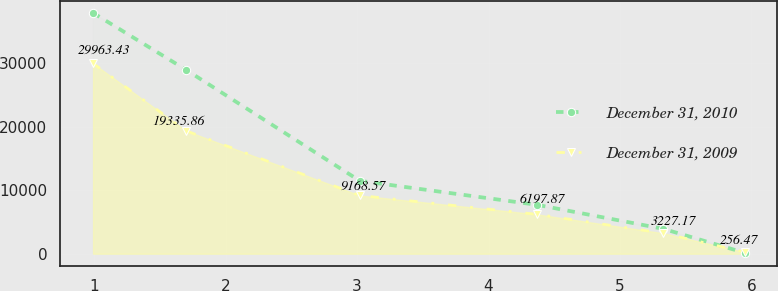Convert chart to OTSL. <chart><loc_0><loc_0><loc_500><loc_500><line_chart><ecel><fcel>December 31, 2010<fcel>December 31, 2009<nl><fcel>0.99<fcel>37918.2<fcel>29963.4<nl><fcel>1.7<fcel>28927.6<fcel>19335.9<nl><fcel>3.02<fcel>11476.4<fcel>9168.57<nl><fcel>4.37<fcel>7699.04<fcel>6197.87<nl><fcel>5.33<fcel>3921.64<fcel>3227.17<nl><fcel>5.95<fcel>144.24<fcel>256.47<nl></chart> 